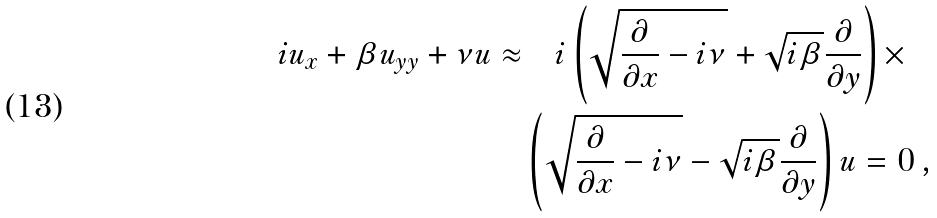<formula> <loc_0><loc_0><loc_500><loc_500>i u _ { x } + \beta u _ { y y } + \nu u \approx & \quad i \left ( \sqrt { \frac { \partial } { \partial x } - i \nu } + \sqrt { i \beta } \frac { \partial } { \partial y } \right ) \times \\ & \left ( \sqrt { \frac { \partial } { \partial x } - i \nu } - \sqrt { i \beta } \frac { \partial } { \partial y } \right ) u = 0 \, ,</formula> 